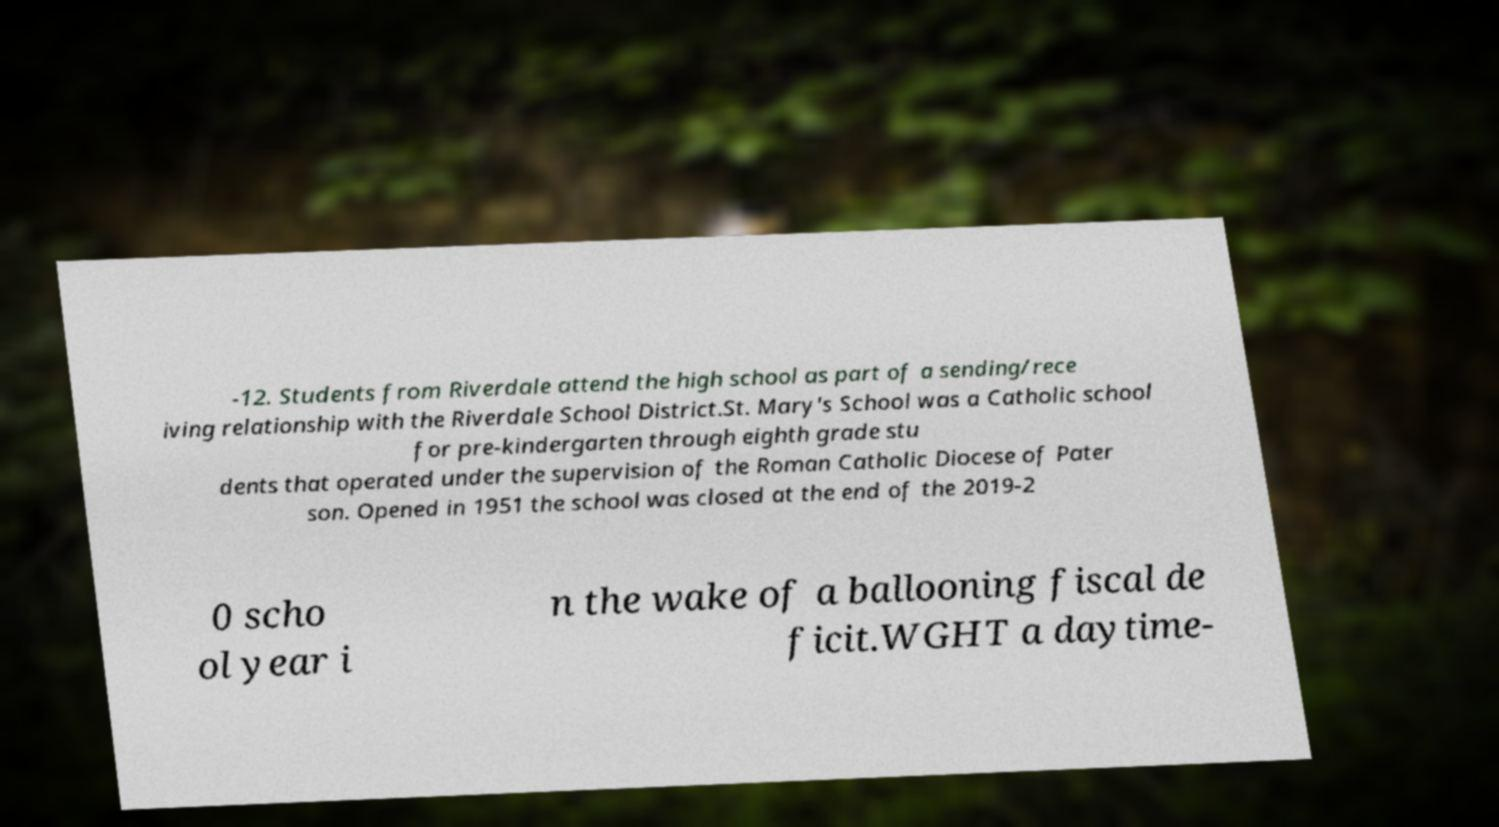Could you assist in decoding the text presented in this image and type it out clearly? -12. Students from Riverdale attend the high school as part of a sending/rece iving relationship with the Riverdale School District.St. Mary's School was a Catholic school for pre-kindergarten through eighth grade stu dents that operated under the supervision of the Roman Catholic Diocese of Pater son. Opened in 1951 the school was closed at the end of the 2019-2 0 scho ol year i n the wake of a ballooning fiscal de ficit.WGHT a daytime- 